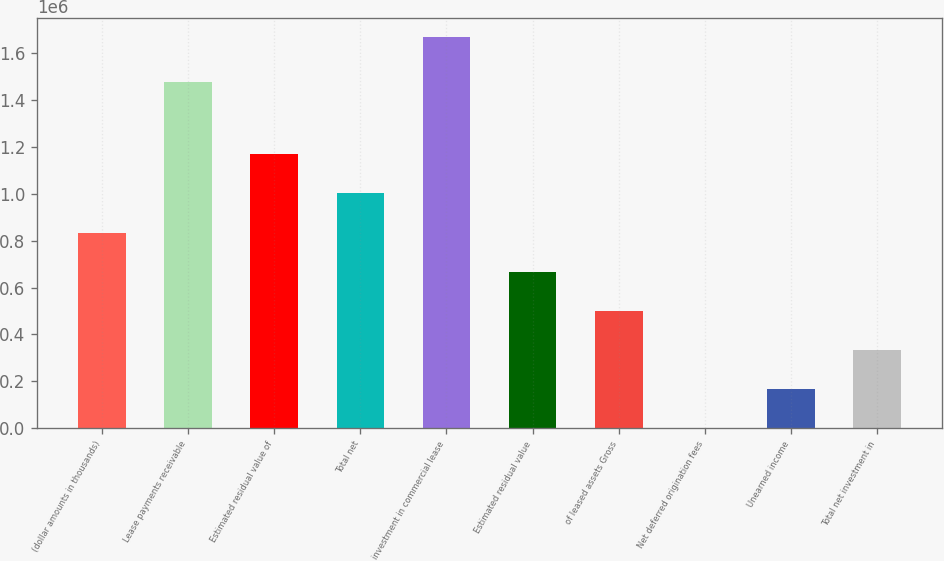Convert chart to OTSL. <chart><loc_0><loc_0><loc_500><loc_500><bar_chart><fcel>(dollar amounts in thousands)<fcel>Lease payments receivable<fcel>Estimated residual value of<fcel>Total net<fcel>investment in commercial lease<fcel>Estimated residual value<fcel>of leased assets Gross<fcel>Net deferred origination fees<fcel>Unearned income<fcel>Total net investment in<nl><fcel>834784<fcel>1.4773e+06<fcel>1.1687e+06<fcel>1.00174e+06<fcel>1.66957e+06<fcel>667828<fcel>500871<fcel>2<fcel>166958<fcel>333915<nl></chart> 